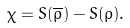Convert formula to latex. <formula><loc_0><loc_0><loc_500><loc_500>\chi = S ( \overline { \rho } ) - S ( \rho ) .</formula> 